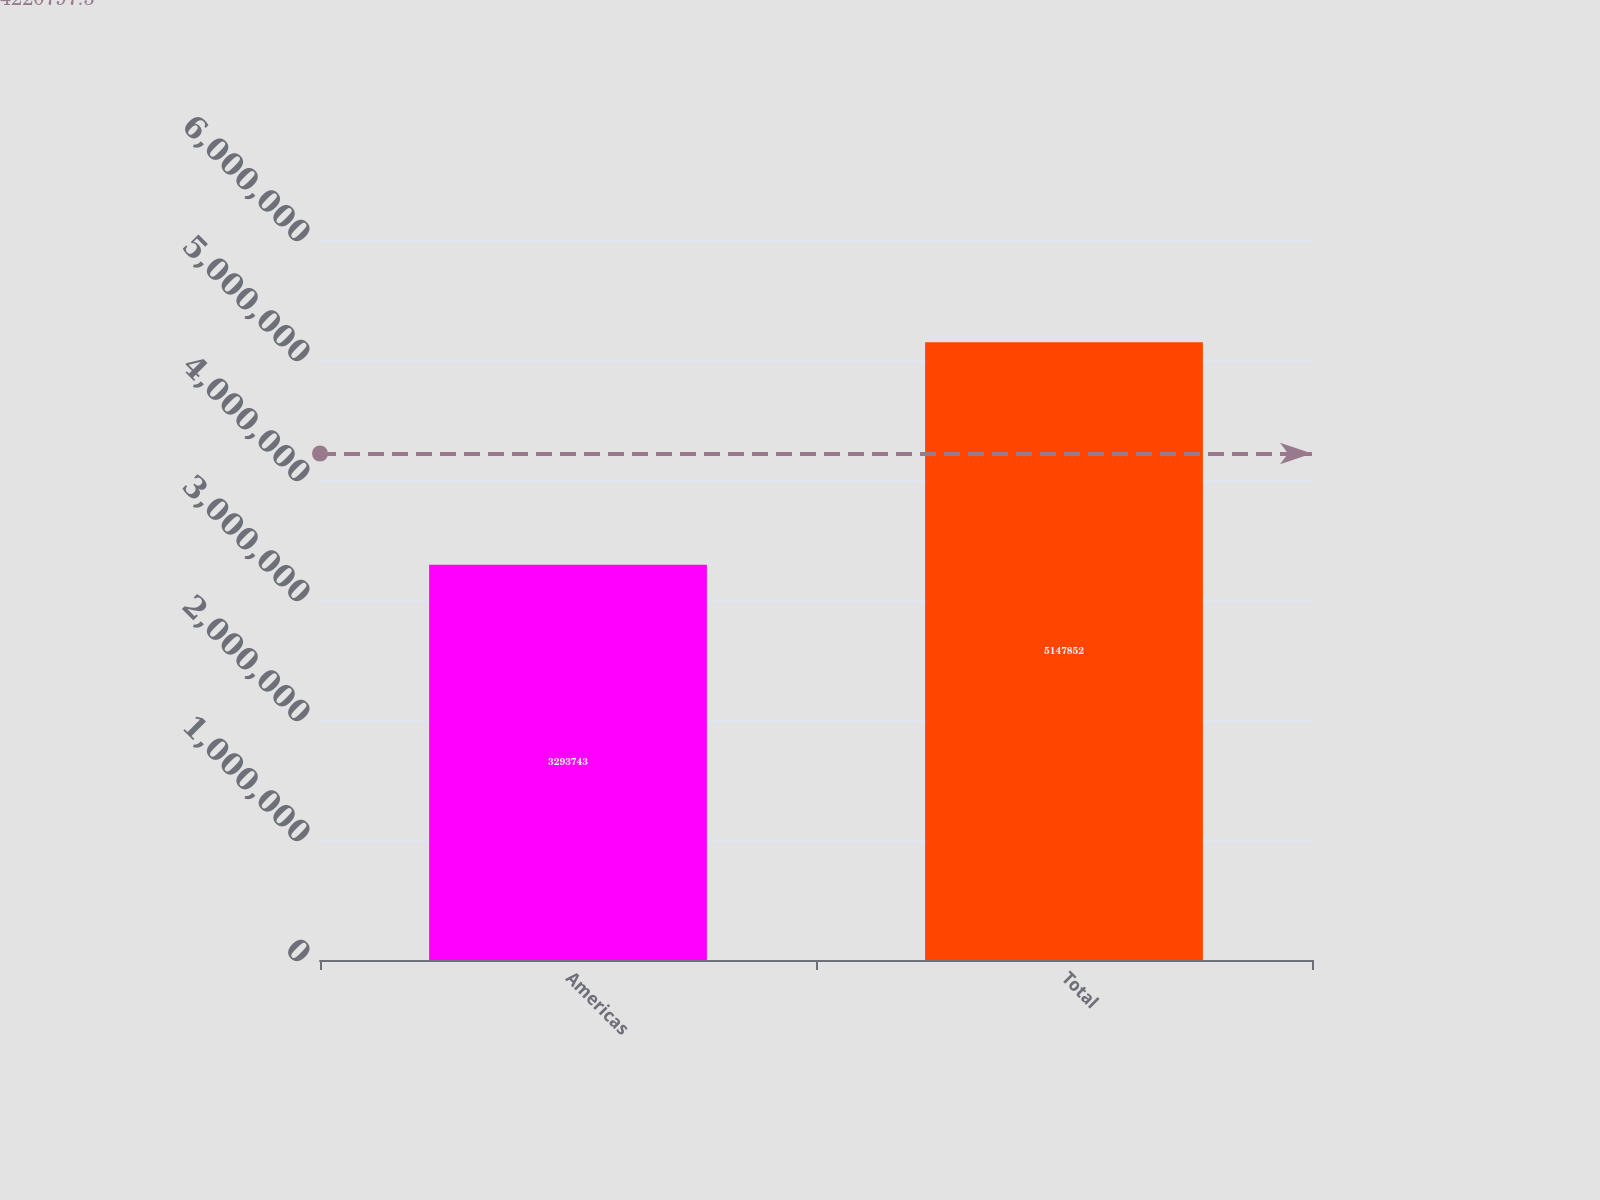<chart> <loc_0><loc_0><loc_500><loc_500><bar_chart><fcel>Americas<fcel>Total<nl><fcel>3.29374e+06<fcel>5.14785e+06<nl></chart> 